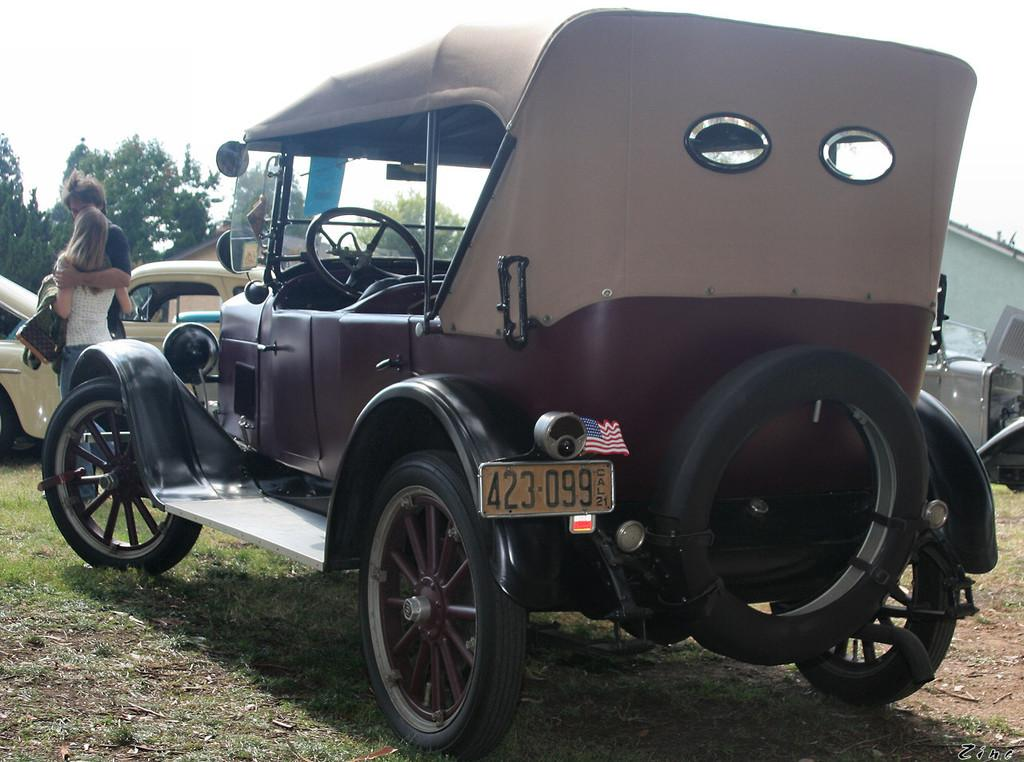How many people are present in the image? There is a man and a woman in the image. What types of vehicles can be seen in the image? There are vehicles in the image, but the specific types are not mentioned. What is the natural environment visible in the image? There is grass visible in the image, and trees and the sky are visible in the background. What type of cracker is the man holding in the image? There is no cracker present in the image. What rhythm is the woman dancing to in the image? There is no dancing or rhythm present in the image. 